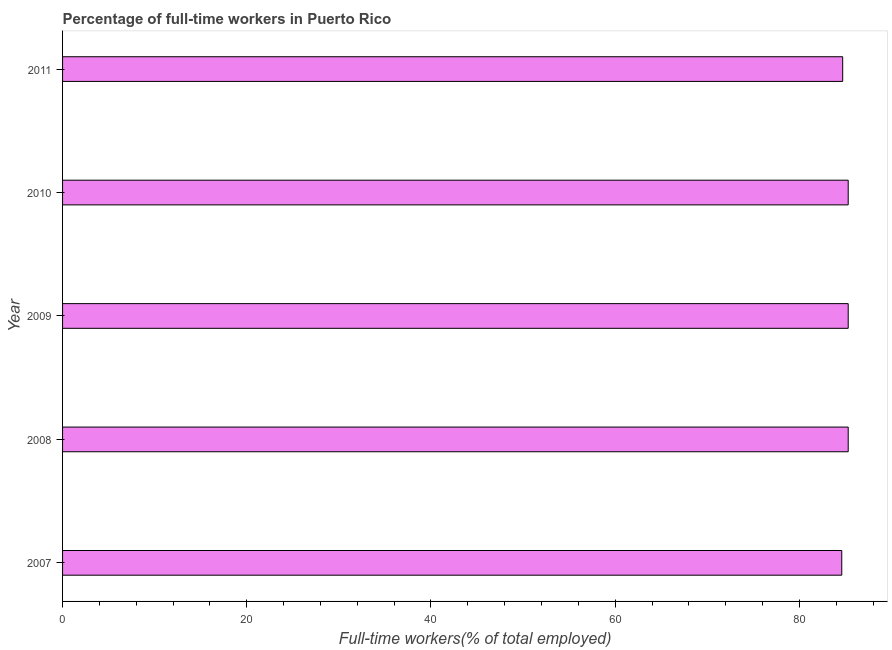What is the title of the graph?
Ensure brevity in your answer.  Percentage of full-time workers in Puerto Rico. What is the label or title of the X-axis?
Provide a short and direct response. Full-time workers(% of total employed). What is the percentage of full-time workers in 2007?
Make the answer very short. 84.6. Across all years, what is the maximum percentage of full-time workers?
Provide a short and direct response. 85.3. Across all years, what is the minimum percentage of full-time workers?
Offer a very short reply. 84.6. In which year was the percentage of full-time workers maximum?
Your response must be concise. 2008. In which year was the percentage of full-time workers minimum?
Ensure brevity in your answer.  2007. What is the sum of the percentage of full-time workers?
Your response must be concise. 425.2. What is the average percentage of full-time workers per year?
Your response must be concise. 85.04. What is the median percentage of full-time workers?
Your response must be concise. 85.3. Is the percentage of full-time workers in 2010 less than that in 2011?
Make the answer very short. No. What is the difference between the highest and the second highest percentage of full-time workers?
Make the answer very short. 0. What is the difference between the highest and the lowest percentage of full-time workers?
Provide a short and direct response. 0.7. How many bars are there?
Ensure brevity in your answer.  5. Are all the bars in the graph horizontal?
Your response must be concise. Yes. How many years are there in the graph?
Give a very brief answer. 5. What is the difference between two consecutive major ticks on the X-axis?
Your answer should be compact. 20. What is the Full-time workers(% of total employed) in 2007?
Provide a short and direct response. 84.6. What is the Full-time workers(% of total employed) of 2008?
Your response must be concise. 85.3. What is the Full-time workers(% of total employed) in 2009?
Offer a terse response. 85.3. What is the Full-time workers(% of total employed) in 2010?
Offer a very short reply. 85.3. What is the Full-time workers(% of total employed) in 2011?
Ensure brevity in your answer.  84.7. What is the difference between the Full-time workers(% of total employed) in 2007 and 2010?
Make the answer very short. -0.7. What is the difference between the Full-time workers(% of total employed) in 2008 and 2009?
Give a very brief answer. 0. What is the difference between the Full-time workers(% of total employed) in 2008 and 2011?
Your response must be concise. 0.6. What is the difference between the Full-time workers(% of total employed) in 2009 and 2010?
Make the answer very short. 0. What is the difference between the Full-time workers(% of total employed) in 2009 and 2011?
Provide a short and direct response. 0.6. What is the difference between the Full-time workers(% of total employed) in 2010 and 2011?
Make the answer very short. 0.6. What is the ratio of the Full-time workers(% of total employed) in 2007 to that in 2009?
Your response must be concise. 0.99. What is the ratio of the Full-time workers(% of total employed) in 2007 to that in 2010?
Give a very brief answer. 0.99. What is the ratio of the Full-time workers(% of total employed) in 2008 to that in 2009?
Provide a succinct answer. 1. What is the ratio of the Full-time workers(% of total employed) in 2008 to that in 2010?
Ensure brevity in your answer.  1. What is the ratio of the Full-time workers(% of total employed) in 2009 to that in 2010?
Give a very brief answer. 1. What is the ratio of the Full-time workers(% of total employed) in 2009 to that in 2011?
Your answer should be very brief. 1.01. 